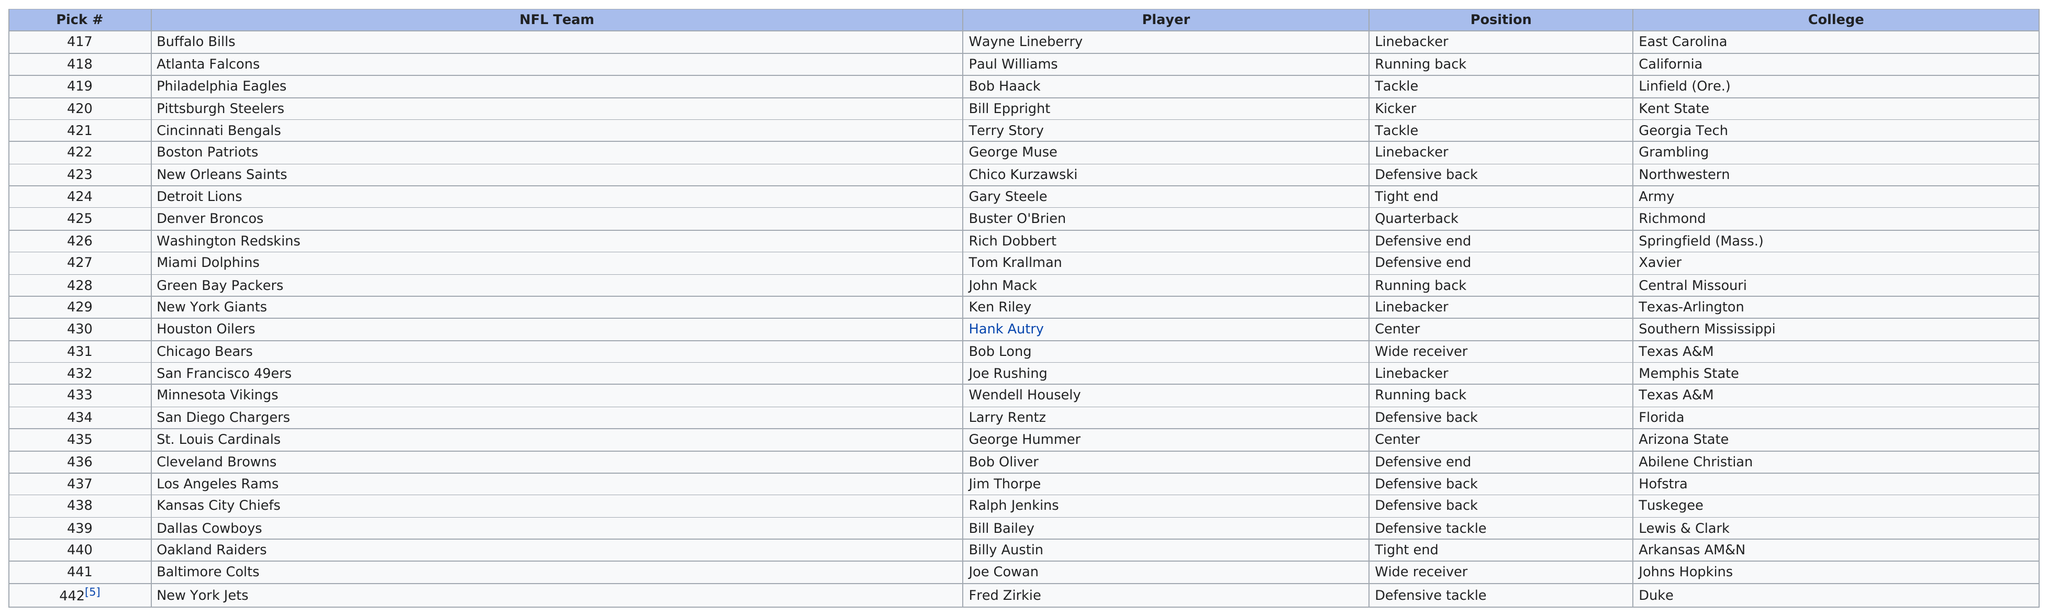List a handful of essential elements in this visual. Four defensive back players were selected in the draft. In the 1969 NFL Draft, a total of four linebackers were chosen in Round 17. After the Detroit Lions chose Gary Steele, the Denver Broncos were the next team in the draft order. There are 25 different players listed in this table. On April 20, 1969, the Chicago Bears selected Bob Long in the first round of the NFL draft, making him the 13th overall pick. What may come as a surprise to some is that Long attended the same college as another player who was also drafted in the 17th round of the same draft: Wendell Housely. 